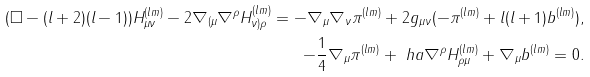<formula> <loc_0><loc_0><loc_500><loc_500>( \Box - ( l + 2 ) ( l - 1 ) ) H _ { \mu \nu } ^ { ( l m ) } - 2 \nabla _ { ( \mu } \nabla ^ { \rho } H _ { \nu ) \rho } ^ { ( l m ) } = - \nabla _ { \mu } \nabla _ { \nu } \pi ^ { ( l m ) } + 2 g _ { \mu \nu } ( - \pi ^ { ( l m ) } + l ( l + 1 ) b ^ { ( l m ) } ) , \\ - \frac { 1 } { 4 } \nabla _ { \mu } \pi ^ { ( l m ) } + \ h a \nabla ^ { \rho } { H ^ { ( l m ) } _ { \rho \mu } } + \nabla _ { \mu } b ^ { ( l m ) } = 0 .</formula> 